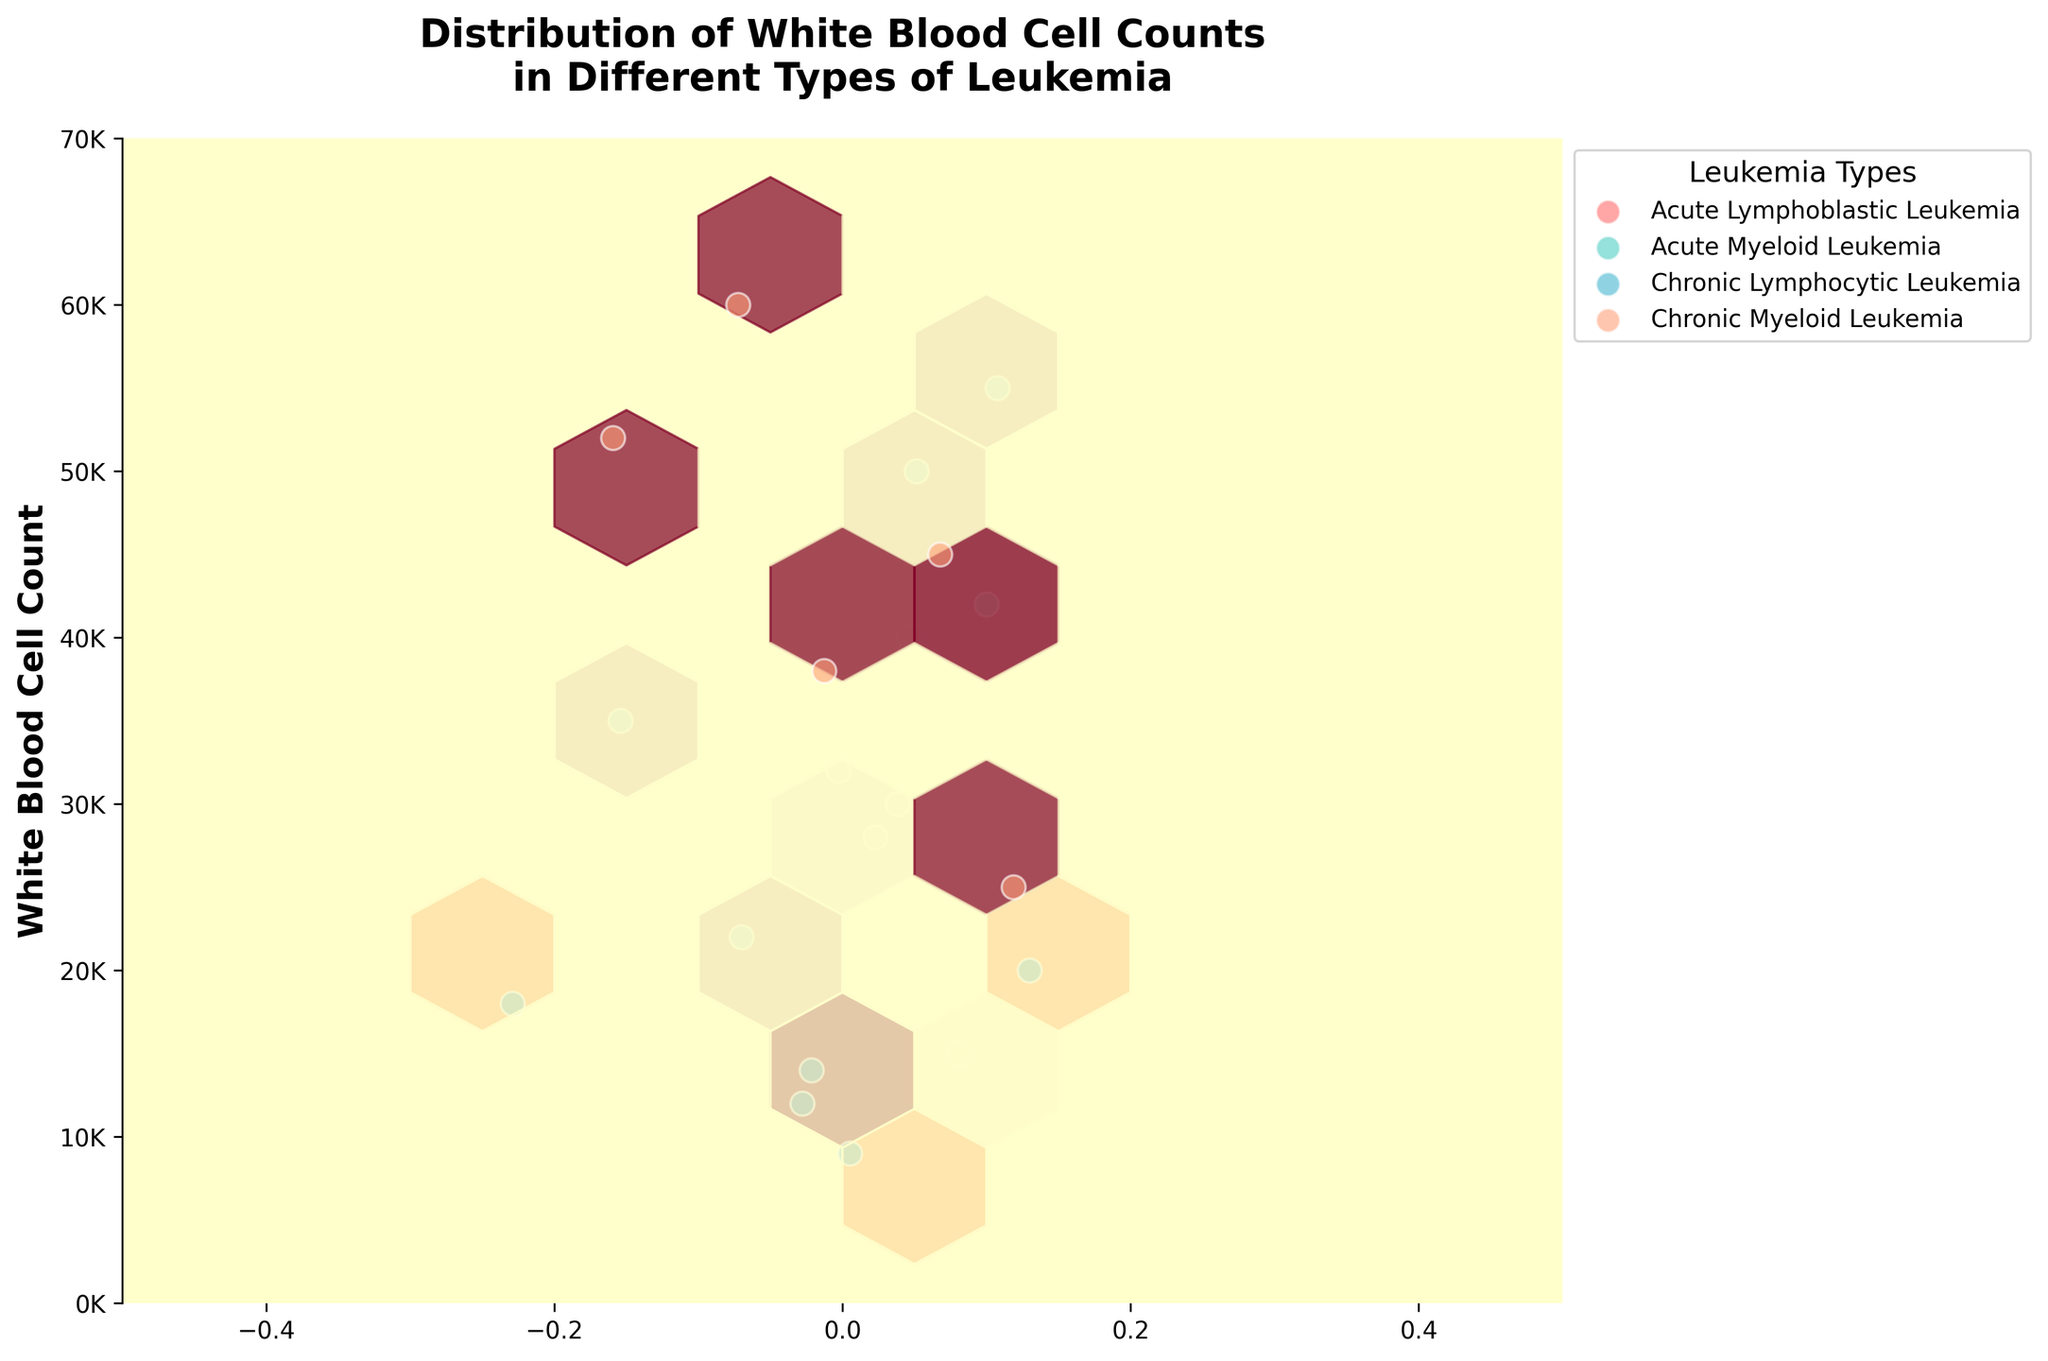What does the title of the figure indicate? The title "Distribution of White Blood Cell Counts in Different Types of Leukemia" indicates that the figure shows how white blood cell counts are distributed among patients with different types of leukemia.
Answer: Distribution of White Blood Cell Counts in Different Types of Leukemia What types of leukemia are represented in the plot? The legend on the plot lists the types of leukemia represented as Acute Lymphoblastic Leukemia, Acute Myeloid Leukemia, Chronic Lymphocytic Leukemia, and Chronic Myeloid Leukemia.
Answer: Acute Lymphoblastic Leukemia, Acute Myeloid Leukemia, Chronic Lymphocytic Leukemia, Chronic Myeloid Leukemia Which type of leukemia has the highest white blood cell count observation? From the y-axis and the data points, it can be seen that Chronic Myeloid Leukemia has the highest observed white blood cell count.
Answer: Chronic Myeloid Leukemia Are the white blood cell counts for Acute Lymphoblastic Leukemia and Acute Myeloid Leukemia similar? Observing the scatter points and the color-coded hexbin density, both Acute Lymphoblastic Leukemia and Acute Myeloid Leukemia show overlapping WBC counts, generally ranging between approximately 15000 to 50000, indicating a similar distribution.
Answer: Yes For which type of leukemia is the average white blood cell count the highest? Comparing the density and scatter points of each leukemia type:
1. Chronic Myeloid Leukemia clusters around higher values with many points above 40000.
2. Acute Myeloid Leukemia also has high values but not as consistently high as Chronic Myeloid Leukemia.
Thus, Chronic Myeloid Leukemia shows a higher average WBC count.
Answer: Chronic Myeloid Leukemia How does the WBC count in Chronic Lymphocytic Leukemia compare to Acute Myeloid Leukemia? Comparing the scatter points and the density, Chronic Lymphocytic Leukemia generally exhibits lower WBC counts, mainly clustering below 20000, whereas Acute Myeloid Leukemia has a broader range extending up to 55000.
Answer: Chronic Lymphocytic Leukemia has lower WBC counts What is the WBC count range observed for Chronic Myeloid Leukemia in the plot? From the scatter points associated with Chronic Myeloid Leukemia, the WBC counts range from approximately 25000 to 60000.
Answer: 25000 to 60000 Which leukemia type has the lowest WBC count in the plot? Observing the y-axis for the lowest point for each leukemia type, Chronic Lymphocytic Leukemia has the lowest observed WBC, close to 9000.
Answer: Chronic Lymphocytic Leukemia Which leukemias have a significant overlap in their white blood cell counts? Acute Lymphoblastic Leukemia and Acute Myeloid Leukemia share a considerable range and distribution of WBC counts between approximately 15000 and 50000, indicating significant overlap.
Answer: Acute Lymphoblastic Leukemia and Acute Myeloid Leukemia Do any leukemia types have non-overlapping WBC count ranges? Comparing WBC count ranges:
1. Acute Lymphoblastic Leukemia vs. Chronic Lymphocytic Leukemia: Overlapping.
2. Acute Myeloid Leukemia vs. Chronic Lymphocytic Leukemia: Overlapping.
3. Chronic Myeloid Leukemia has values mostly above others like Chronic Lymphocytic Leukemia, which clusters below 20000.
Thus, Chronic Myeloid Leukemia vs. Chronic Lymphocytic Leukemia shows non-overlapping ranges.
Answer: Chronic Myeloid Leukemia and Chronic Lymphocytic Leukemia 